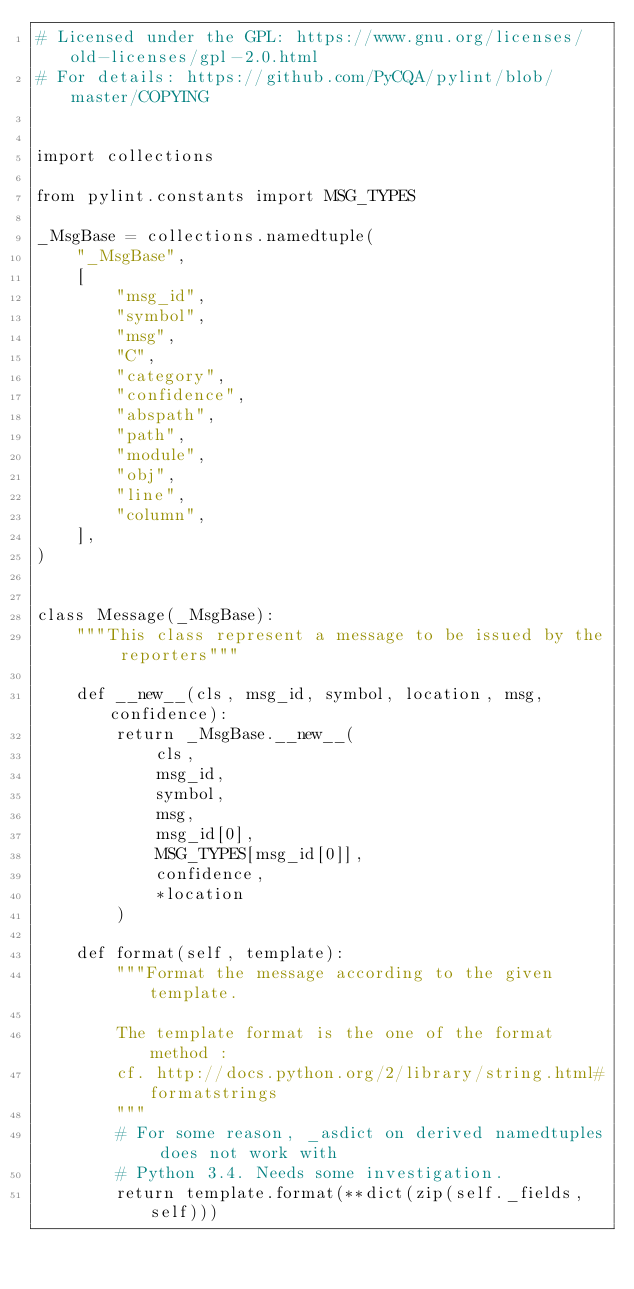<code> <loc_0><loc_0><loc_500><loc_500><_Python_># Licensed under the GPL: https://www.gnu.org/licenses/old-licenses/gpl-2.0.html
# For details: https://github.com/PyCQA/pylint/blob/master/COPYING


import collections

from pylint.constants import MSG_TYPES

_MsgBase = collections.namedtuple(
    "_MsgBase",
    [
        "msg_id",
        "symbol",
        "msg",
        "C",
        "category",
        "confidence",
        "abspath",
        "path",
        "module",
        "obj",
        "line",
        "column",
    ],
)


class Message(_MsgBase):
    """This class represent a message to be issued by the reporters"""

    def __new__(cls, msg_id, symbol, location, msg, confidence):
        return _MsgBase.__new__(
            cls,
            msg_id,
            symbol,
            msg,
            msg_id[0],
            MSG_TYPES[msg_id[0]],
            confidence,
            *location
        )

    def format(self, template):
        """Format the message according to the given template.

        The template format is the one of the format method :
        cf. http://docs.python.org/2/library/string.html#formatstrings
        """
        # For some reason, _asdict on derived namedtuples does not work with
        # Python 3.4. Needs some investigation.
        return template.format(**dict(zip(self._fields, self)))
</code> 